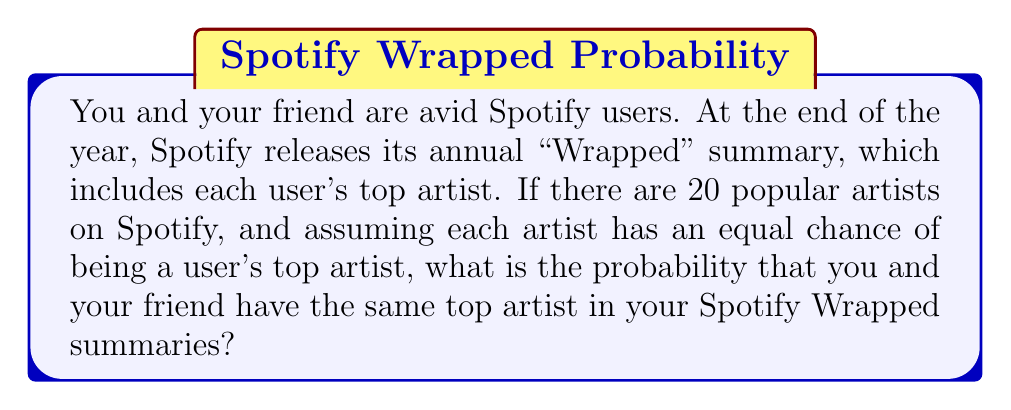Can you answer this question? Let's approach this step-by-step:

1) First, we need to understand what the question is asking. We're looking for the probability that two independent users have the same top artist out of 20 possible artists.

2) The probability of you having any specific artist as your top artist is $\frac{1}{20}$, as there are 20 artists in total and each has an equal chance.

3) For your friend to have the same top artist as you, two events need to occur:
   a) You have a specific artist as your top artist (probability $\frac{1}{20}$)
   b) Your friend has the same artist as their top artist (also probability $\frac{1}{20}$)

4) The probability of both these events occurring is the product of their individual probabilities:

   $$P(\text{same artist}) = \frac{1}{20} \times \frac{1}{20} = \frac{1}{400}$$

5) However, this is the probability for any specific artist. The question asks for the probability of having the same artist, regardless of which artist it is.

6) There are 20 possible ways this can happen (you could both have artist 1, or both have artist 2, etc.), and each of these has a probability of $\frac{1}{400}$.

7) To find the total probability, we sum these 20 possibilities:

   $$P(\text{same artist}) = 20 \times \frac{1}{400} = \frac{20}{400} = \frac{1}{20} = 0.05$$

Thus, the probability is $\frac{1}{20}$ or 0.05 or 5%.
Answer: $\frac{1}{20}$ or 0.05 or 5% 